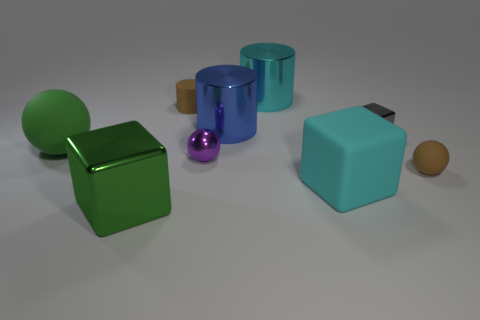Add 1 cyan shiny cylinders. How many objects exist? 10 Subtract 1 balls. How many balls are left? 2 Subtract all balls. How many objects are left? 6 Subtract 0 yellow spheres. How many objects are left? 9 Subtract all tiny shiny objects. Subtract all small rubber cubes. How many objects are left? 7 Add 5 purple shiny objects. How many purple shiny objects are left? 6 Add 8 big blue matte things. How many big blue matte things exist? 8 